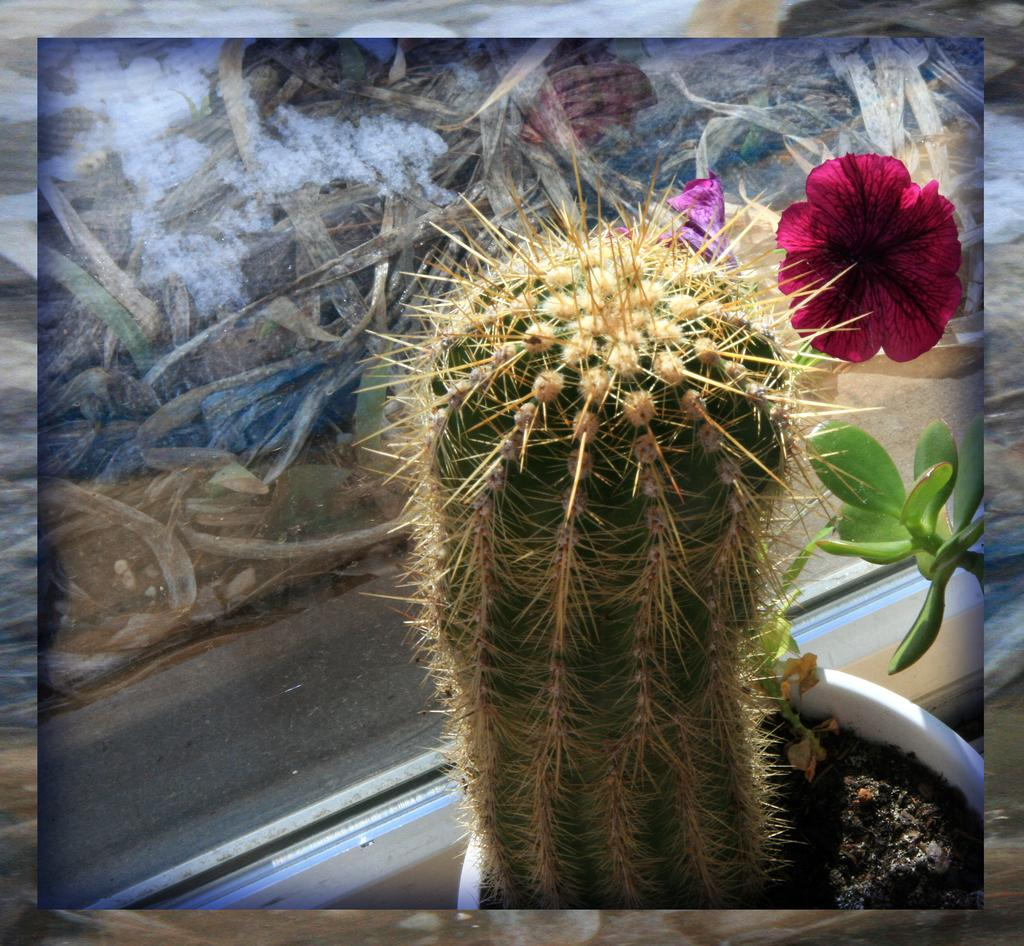What type of plant is in a pot in the image? There is a plant in a pot in the image, but the specific type of plant cannot be determined from the provided facts. Are there any other plants in the image besides the one in the pot? Yes, there is another plant in the image. What can be seen in the image besides plants? There are flowers and objects in the image. Can you describe the background of the image? The background of the image is not clear to describe based on the provided facts. What type of disease is affecting the plant in the image? There is no indication of any disease affecting the plant in the image; it appears to be healthy. Can you tell me how many times the plant was kicked in the image? There is no mention of any kicking or physical interaction with the plant in the image. 